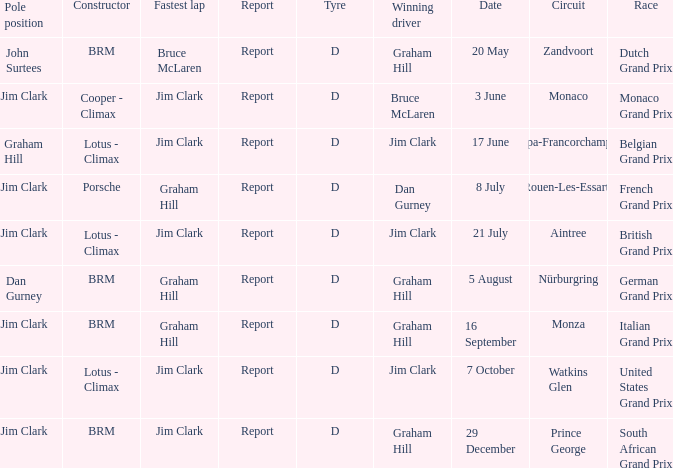What is the date of the circuit of nürburgring, which had Graham Hill as the winning driver? 5 August. 